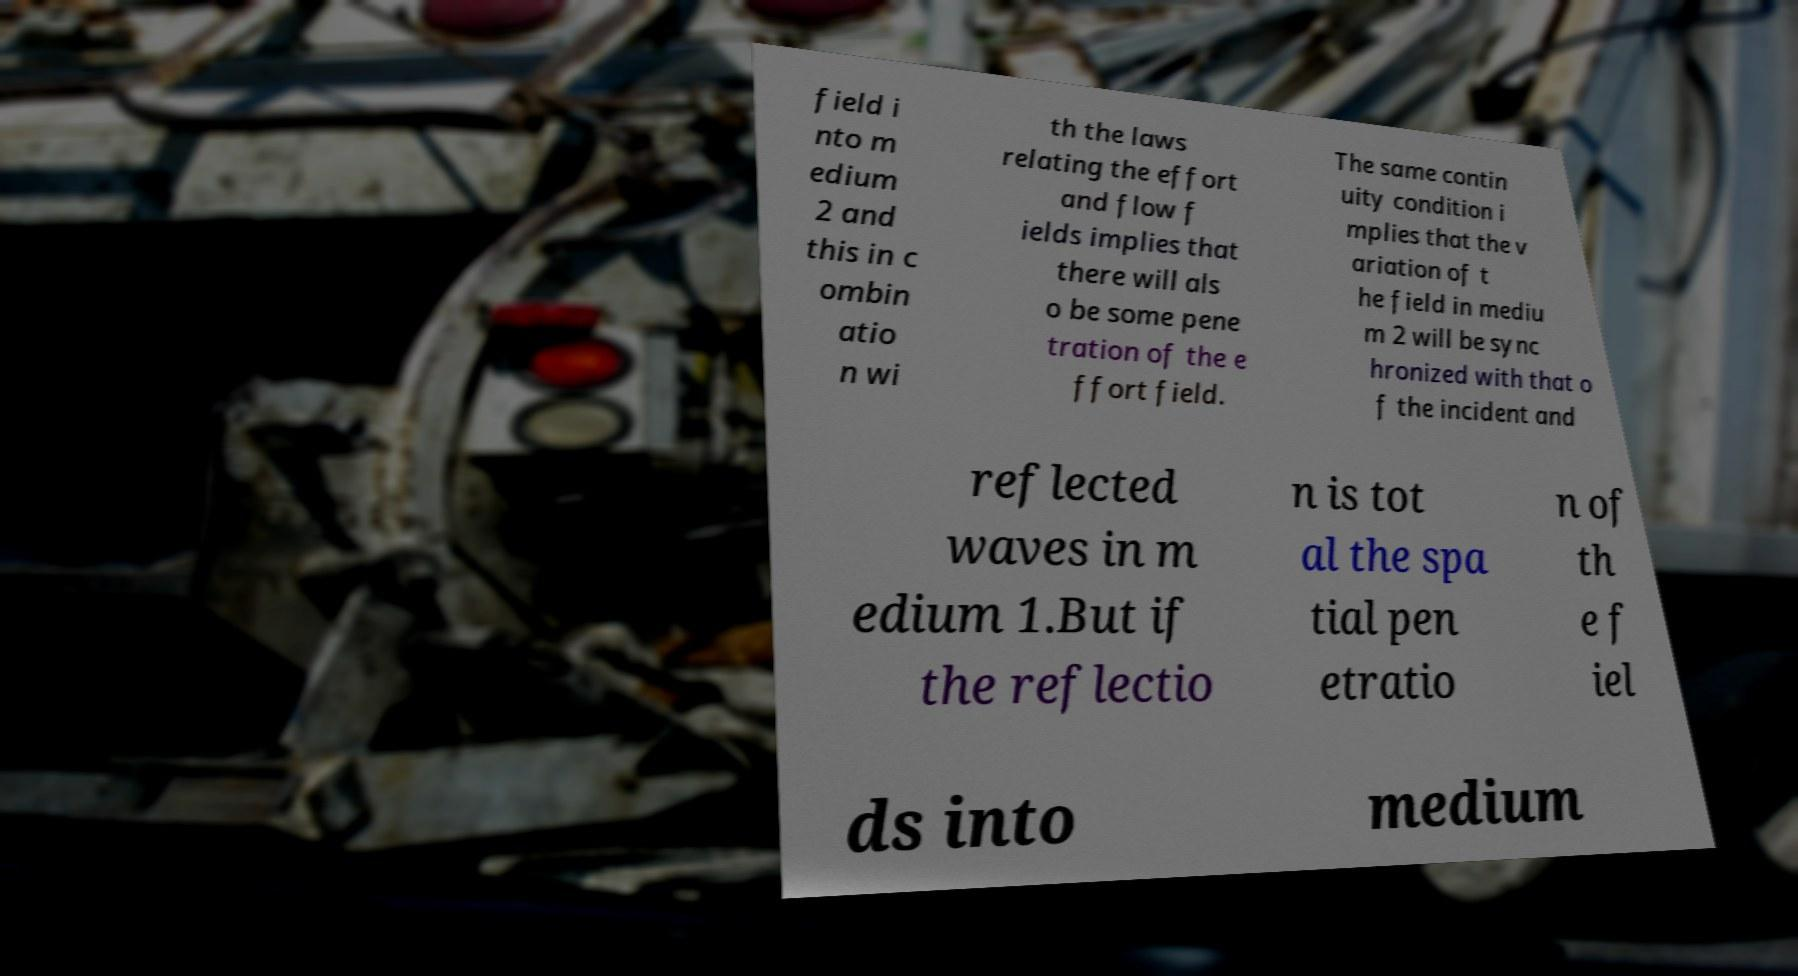I need the written content from this picture converted into text. Can you do that? field i nto m edium 2 and this in c ombin atio n wi th the laws relating the effort and flow f ields implies that there will als o be some pene tration of the e ffort field. The same contin uity condition i mplies that the v ariation of t he field in mediu m 2 will be sync hronized with that o f the incident and reflected waves in m edium 1.But if the reflectio n is tot al the spa tial pen etratio n of th e f iel ds into medium 